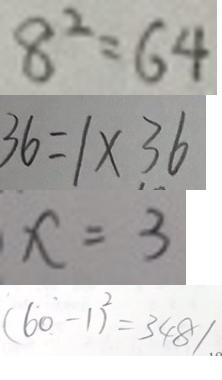<formula> <loc_0><loc_0><loc_500><loc_500>8 ^ { 2 } = 6 4 
 3 6 = 1 \times 3 6 
 x = 3 
 ( 6 0 - 1 ) ^ { 2 } = 3 4 8 1</formula> 